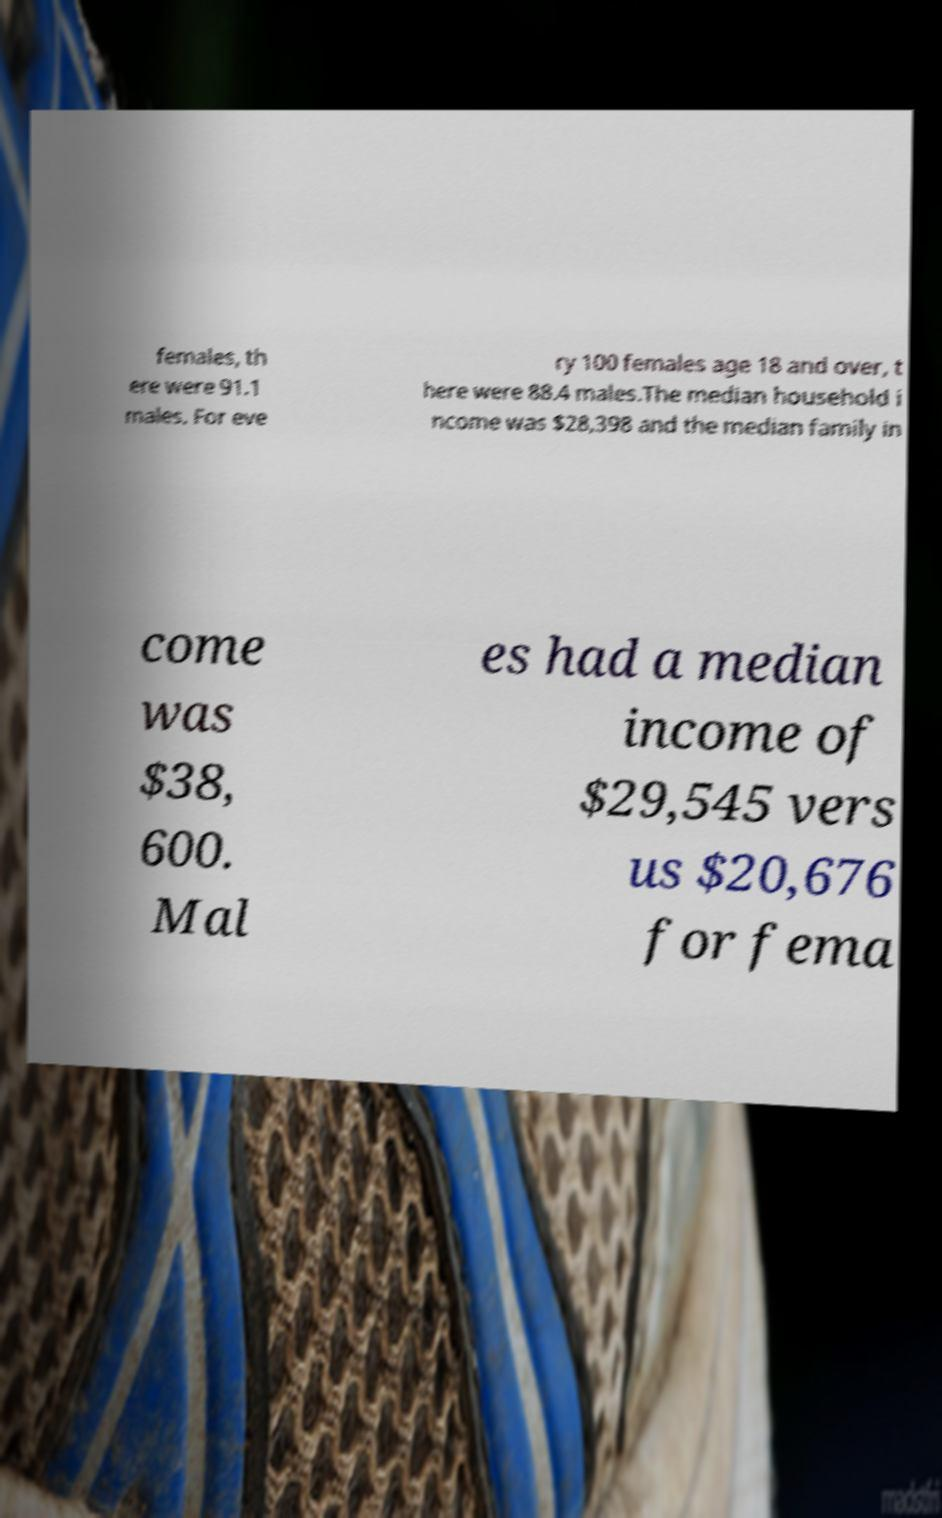Please identify and transcribe the text found in this image. females, th ere were 91.1 males. For eve ry 100 females age 18 and over, t here were 88.4 males.The median household i ncome was $28,398 and the median family in come was $38, 600. Mal es had a median income of $29,545 vers us $20,676 for fema 